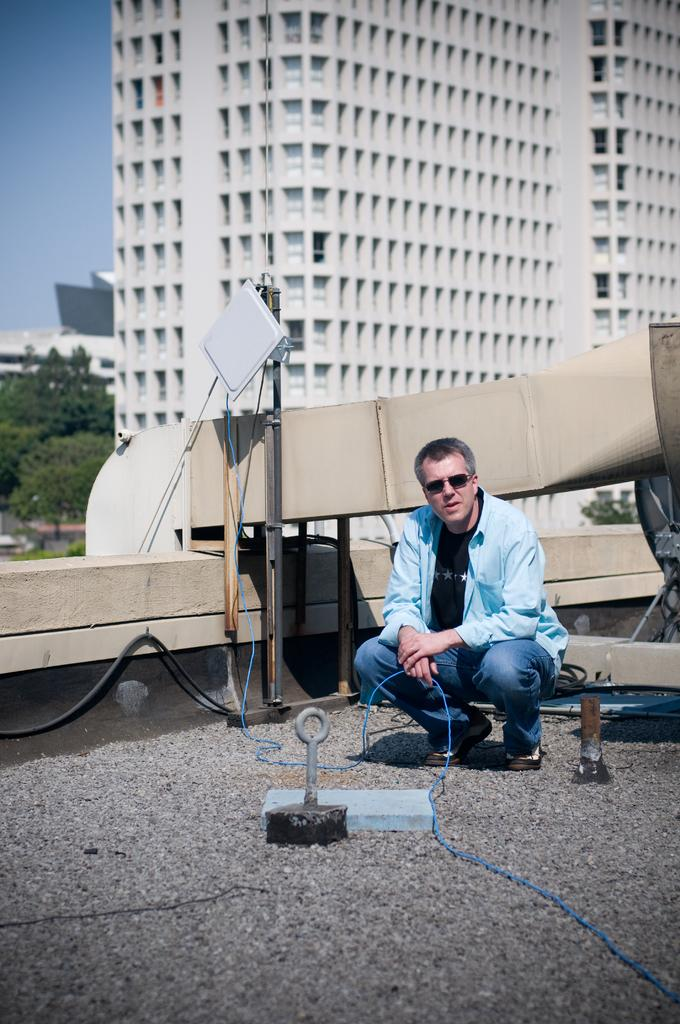What is the person in the image holding? There is a person holding an object in the image. What type of surface can be seen beneath the person? There is ground visible in the image. What else can be found on the ground in the image? There are objects on the ground. What type of man-made structures are present in the image? There are buildings in the image. What type of natural vegetation is present in the image? There are trees in the image. What part of the natural environment is visible in the image? The sky is visible in the image. What type of furniture is visible in the image? There is no furniture present in the image. What type of pets can be seen in the image? There are no pets present in the image. 